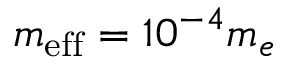<formula> <loc_0><loc_0><loc_500><loc_500>m _ { e f f } = 1 0 ^ { - 4 } m _ { e }</formula> 